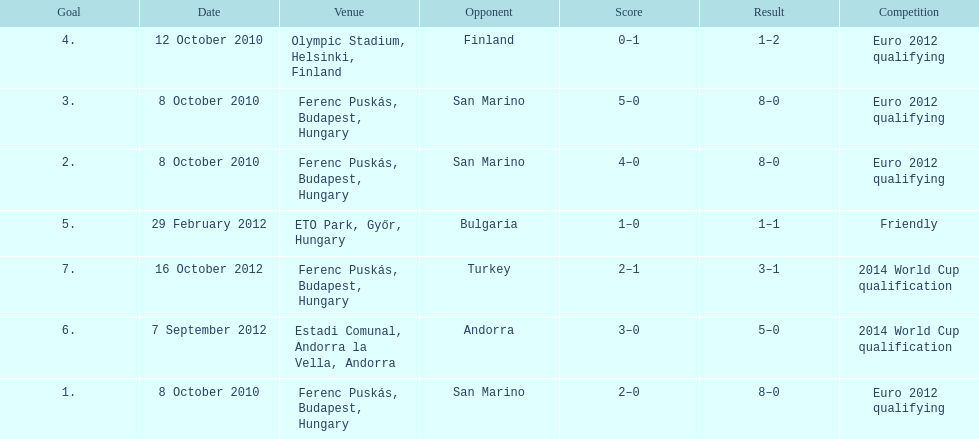How many non-qualifying games did he score in? 1. 